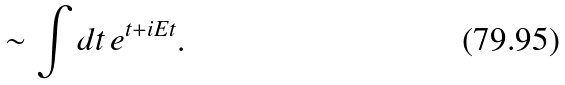Convert formula to latex. <formula><loc_0><loc_0><loc_500><loc_500>\sim \int d t \, e ^ { t + i E t } .</formula> 